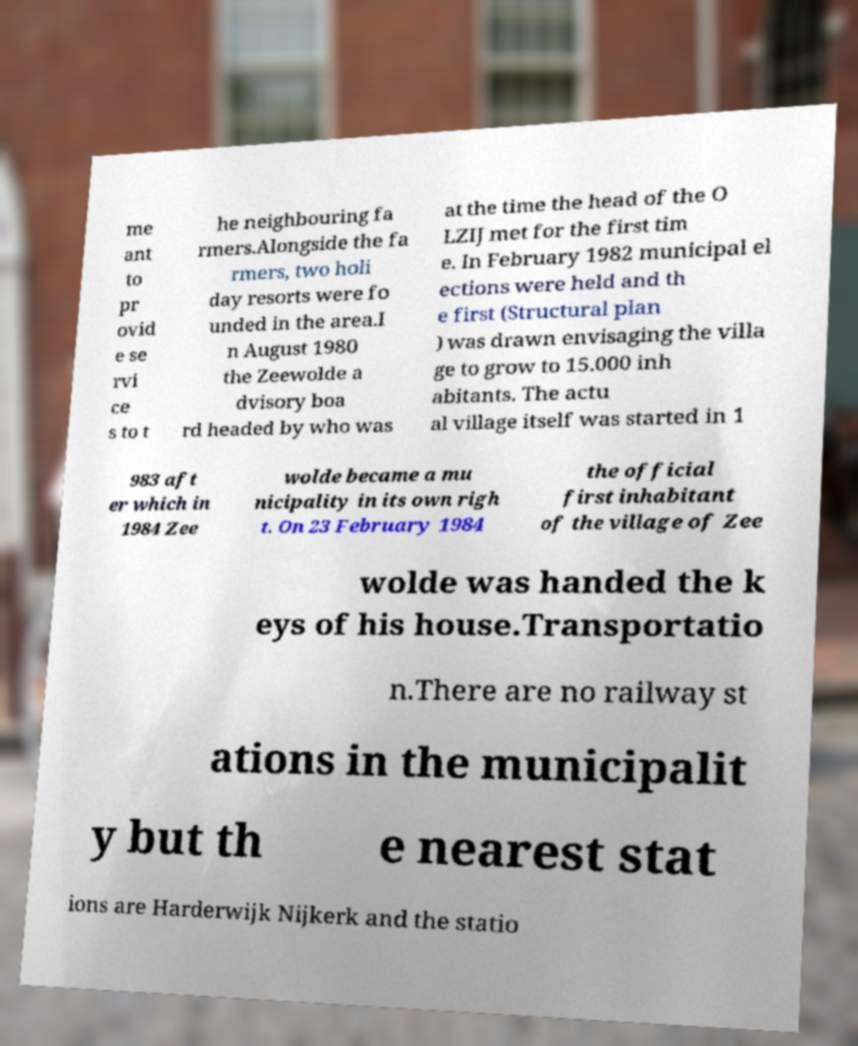I need the written content from this picture converted into text. Can you do that? me ant to pr ovid e se rvi ce s to t he neighbouring fa rmers.Alongside the fa rmers, two holi day resorts were fo unded in the area.I n August 1980 the Zeewolde a dvisory boa rd headed by who was at the time the head of the O LZIJ met for the first tim e. In February 1982 municipal el ections were held and th e first (Structural plan ) was drawn envisaging the villa ge to grow to 15.000 inh abitants. The actu al village itself was started in 1 983 aft er which in 1984 Zee wolde became a mu nicipality in its own righ t. On 23 February 1984 the official first inhabitant of the village of Zee wolde was handed the k eys of his house.Transportatio n.There are no railway st ations in the municipalit y but th e nearest stat ions are Harderwijk Nijkerk and the statio 